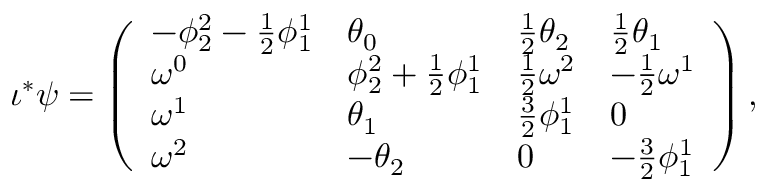Convert formula to latex. <formula><loc_0><loc_0><loc_500><loc_500>\iota ^ { * } \psi = \left ( \begin{array} { l l l l } { - \phi _ { 2 } ^ { 2 } - \frac { 1 } { 2 } \phi _ { 1 } ^ { 1 } } & { \theta _ { 0 } } & { \frac { 1 } { 2 } \theta _ { 2 } } & { \frac { 1 } { 2 } \theta _ { 1 } } \\ { \omega ^ { 0 } } & { \phi _ { 2 } ^ { 2 } + \frac { 1 } { 2 } \phi _ { 1 } ^ { 1 } } & { \frac { 1 } { 2 } \omega ^ { 2 } } & { - \frac { 1 } { 2 } \omega ^ { 1 } } \\ { \omega ^ { 1 } } & { \theta _ { 1 } } & { \frac { 3 } { 2 } \phi _ { 1 } ^ { 1 } } & { 0 } \\ { \omega ^ { 2 } } & { - \theta _ { 2 } } & { 0 } & { - \frac { 3 } { 2 } \phi _ { 1 } ^ { 1 } } \end{array} \right ) ,</formula> 